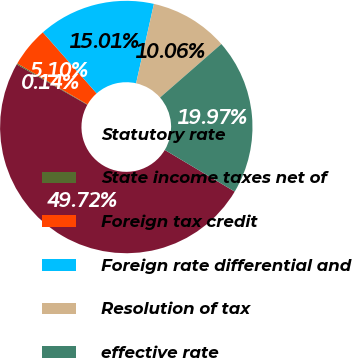Convert chart to OTSL. <chart><loc_0><loc_0><loc_500><loc_500><pie_chart><fcel>Statutory rate<fcel>State income taxes net of<fcel>Foreign tax credit<fcel>Foreign rate differential and<fcel>Resolution of tax<fcel>effective rate<nl><fcel>49.72%<fcel>0.14%<fcel>5.1%<fcel>15.01%<fcel>10.06%<fcel>19.97%<nl></chart> 